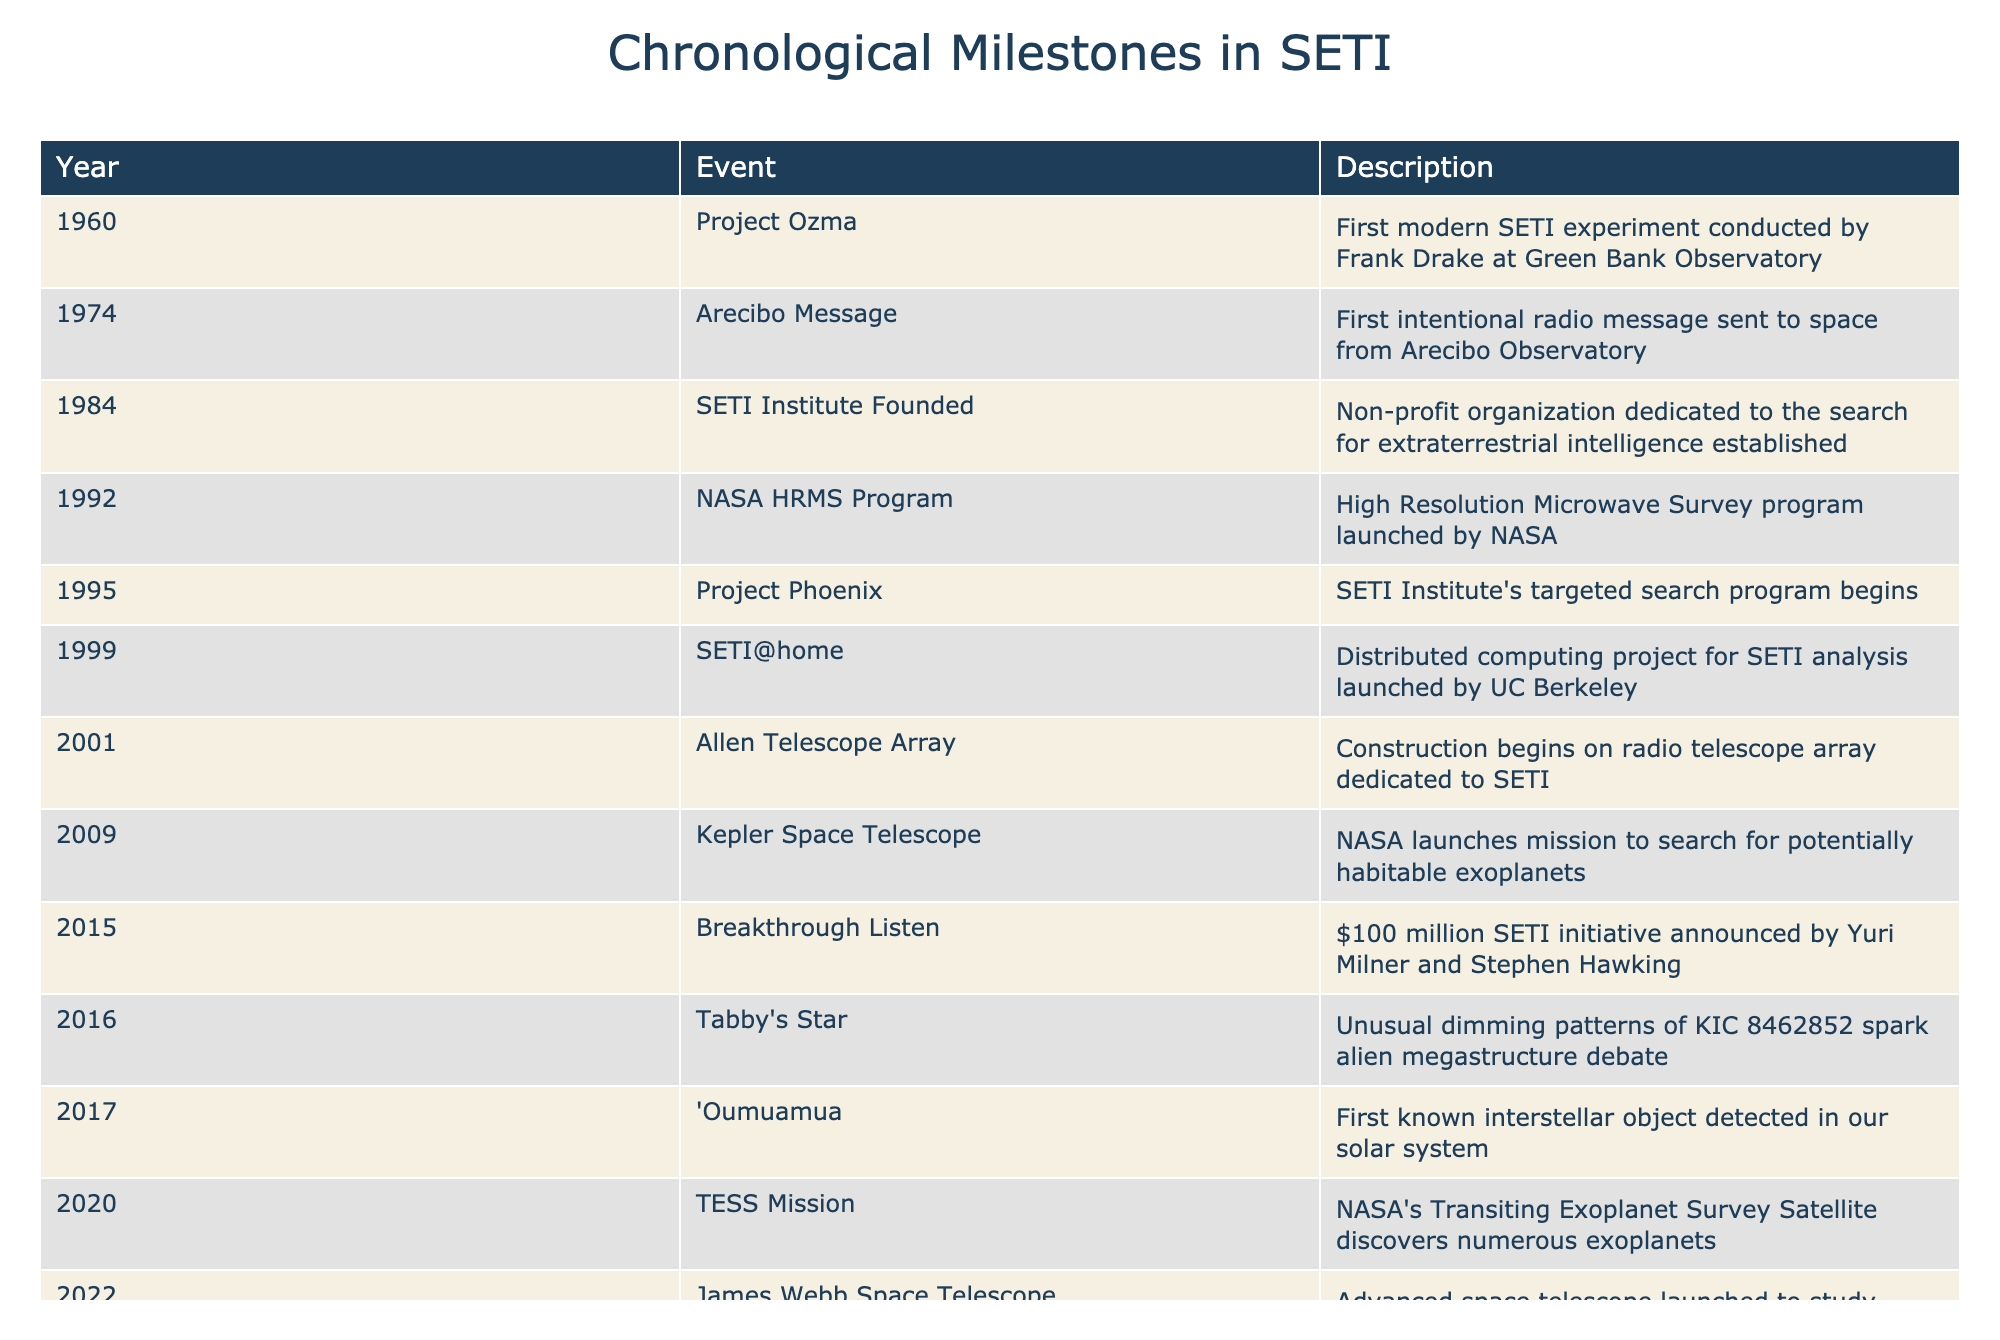What year did the SETI Institute get founded? The founding of the SETI Institute is directly referenced in the table, which states that it occurred in 1984.
Answer: 1984 What is the difference in years between the Arecibo Message and the detection of 'Oumuamua? The Arecibo Message occurred in 1974 and 'Oumuamua was detected in 2017. The difference is 2017 - 1974 = 43 years.
Answer: 43 years Was the Allen Telescope Array constructed before or after the launch of the James Webb Space Telescope? The Allen Telescope Array began construction in 2001, while the James Webb Space Telescope was launched in 2022 as listed in the table. Since 2001 is before 2022, the answer is after.
Answer: After How many major SETI milestones occurred in the 2010s? Reviewing the events in the table for the years from 2010 to 2019: Breakthrough Listen (2015), Tabby's Star (2016), and 'Oumuamua (2017). That totals to three significant milestones.
Answer: 3 Which event marked the first intentional radio message sent to space from Arecibo Observatory? The event listed under the year 1974 in the table is the "Arecibo Message," which is described as the first intentional radio message sent to space.
Answer: Arecibo Message What percentage of the milestones occurred in the 21st century? The milestones in the 21st century (2001 and onwards) are: 2001 (Allen Telescope Array), 2009 (Kepler Space Telescope), 2015 (Breakthrough Listen), 2016 (Tabby's Star), 2017 ('Oumuamua), 2020 (TESS Mission), and 2022 (James Webb Space Telescope). This totals to 7 milestones. The total number of milestones is 13. Therefore, the percentage is (7/13) * 100 ≈ 53.85%.
Answer: 53.85% Did the SETI Institute's targeted search program begin before NASA launched the HRMS Program? The targeted search program called Project Phoenix began in 1995, while the HRMS Program was initiated in 1992. Since 1995 is after 1992, the answer is no.
Answer: No What was the purpose of the Kepler Space Telescope? The table states that the mission of the Kepler Space Telescope, launched in 2009, was to search for potentially habitable exoplanets, which directly answers the question.
Answer: Search for potentially habitable exoplanets How many years apart were the launches of the Kepler Space Telescope and the James Webb Space Telescope? The Kepler Space Telescope was launched in 2009 and the James Webb Space Telescope in 2022. The difference in years is 2022 - 2009 = 13 years.
Answer: 13 years 